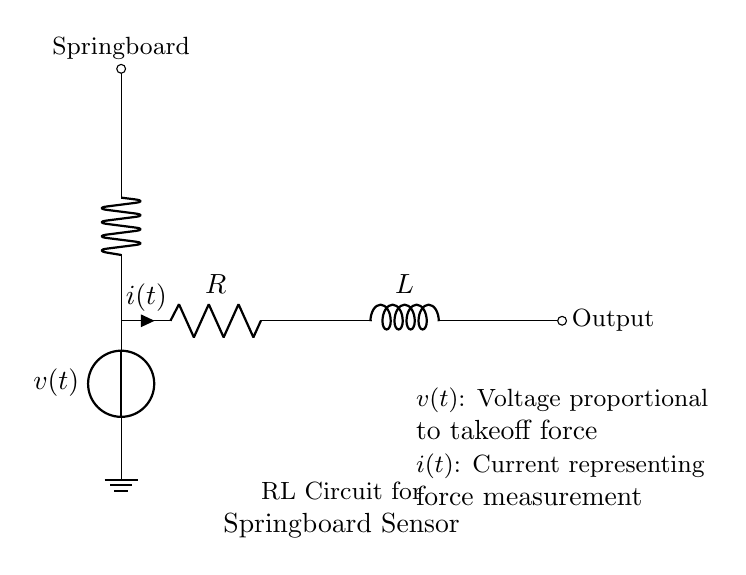What is the voltage source labeled as? The voltage source in the circuit is labeled as v(t), indicating the voltage proportional to the takeoff force of the gymnast.
Answer: v(t) What does the resistor represent in the circuit? The resistor labeled R in the circuit represents the resistance encountered by the current i(t) flowing through it, which is associated with the damping effect in the springboard sensor.
Answer: Resistance What is the output of the circuit? The output of the circuit is indicated as being to the right of the inductor and is labeled as "Output," which shows where the force measurement can be taken from.
Answer: Output What is represented by the current i(t)? The current i(t) in the circuit represents the actual current flowing through the resistor, which in this context measures the force exerted during the gymnast's takeoff.
Answer: Force measurement What type of circuit is illustrated in the diagram? The diagram illustrates an RL circuit, which consists of both a resistor and an inductor connected in series, specifically designed to measure force.
Answer: RL circuit How does the inductor affect the circuit? The inductor L stores energy in a magnetic field when current flows through it, impacting the timing and magnitude of the current response when the gymnast takes off.
Answer: Delays current 